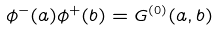<formula> <loc_0><loc_0><loc_500><loc_500>\phi ^ { - } ( a ) \phi ^ { + } ( b ) = G ^ { ( 0 ) } ( a , b )</formula> 